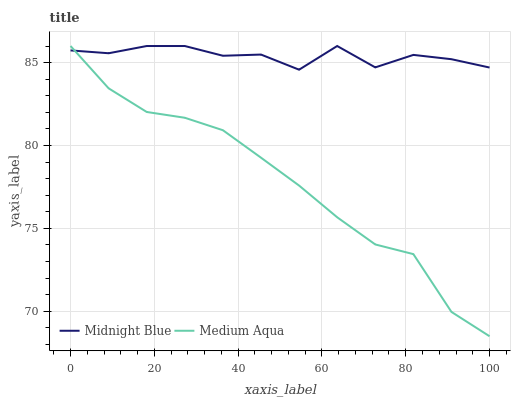Does Midnight Blue have the minimum area under the curve?
Answer yes or no. No. Is Midnight Blue the smoothest?
Answer yes or no. No. Does Midnight Blue have the lowest value?
Answer yes or no. No. 